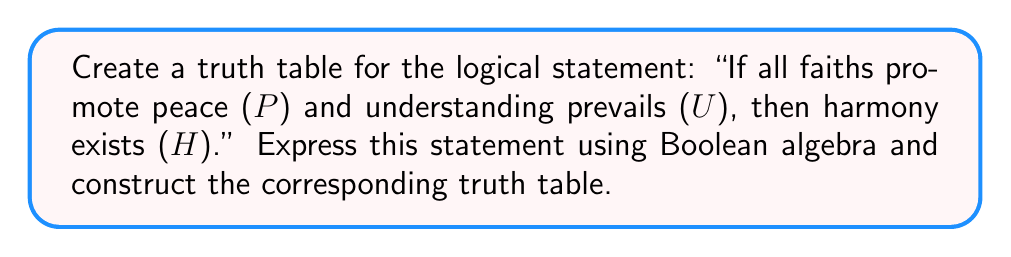Can you answer this question? Let's approach this step-by-step:

1. First, we need to express the statement in Boolean algebra:
   $$(P \land U) \rightarrow H$$

2. We can rewrite this using the equivalent form of implication:
   $$\lnot(P \land U) \lor H$$

3. Now, let's construct the truth table. We have three variables (P, U, and H), so we'll have $2^3 = 8$ rows:

   | P | U | H | $P \land U$ | $\lnot(P \land U)$ | $\lnot(P \land U) \lor H$ |
   |---|---|---|-------------|---------------------|---------------------------|
   | 0 | 0 | 0 |     0       |         1           |            1              |
   | 0 | 0 | 1 |     0       |         1           |            1              |
   | 0 | 1 | 0 |     0       |         1           |            1              |
   | 0 | 1 | 1 |     0       |         1           |            1              |
   | 1 | 0 | 0 |     0       |         1           |            1              |
   | 1 | 0 | 1 |     0       |         1           |            1              |
   | 1 | 1 | 0 |     1       |         0           |            0              |
   | 1 | 1 | 1 |     1       |         0           |            1              |

4. To fill in the truth table:
   a) First, list all possible combinations of P, U, and H.
   b) Calculate $P \land U$.
   c) Calculate $\lnot(P \land U)$.
   d) Finally, calculate $\lnot(P \land U) \lor H$.

5. The resulting truth table shows that the statement is true (1) in all cases except when P and U are both true (1) and H is false (0).

This truth table demonstrates that for peaceful coexistence (H) to be false, it must be the case that all faiths promote peace (P) and understanding prevails (U), yet harmony does not exist. In all other scenarios, the logical statement holds true, reflecting the complex nature of interfaith relations and the conditions necessary for harmony.
Answer: Truth table for $$(P \land U) \rightarrow H$$ or $$\lnot(P \land U) \lor H$$:

| P | U | H | $\lnot(P \land U) \lor H$ |
|---|---|---|---------------------------|
| 0 | 0 | 0 |            1              |
| 0 | 0 | 1 |            1              |
| 0 | 1 | 0 |            1              |
| 0 | 1 | 1 |            1              |
| 1 | 0 | 0 |            1              |
| 1 | 0 | 1 |            1              |
| 1 | 1 | 0 |            0              |
| 1 | 1 | 1 |            1              | 